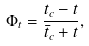Convert formula to latex. <formula><loc_0><loc_0><loc_500><loc_500>\Phi _ { t } = { \frac { t _ { c } - t } { { \bar { t } } _ { c } + t } } ,</formula> 